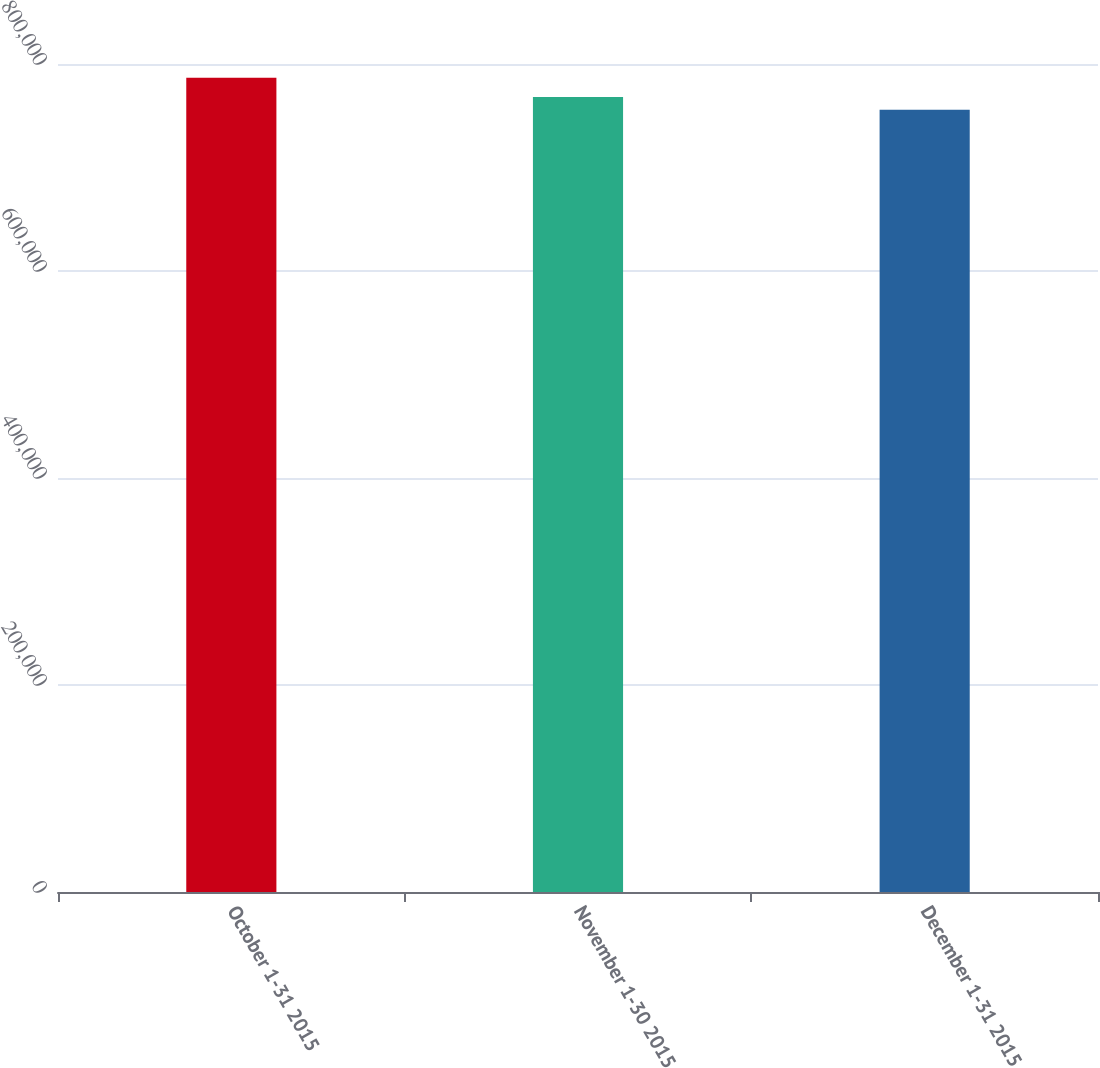Convert chart. <chart><loc_0><loc_0><loc_500><loc_500><bar_chart><fcel>October 1-31 2015<fcel>November 1-30 2015<fcel>December 1-31 2015<nl><fcel>786625<fcel>768226<fcel>755864<nl></chart> 